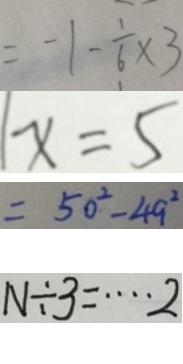Convert formula to latex. <formula><loc_0><loc_0><loc_500><loc_500>= - 1 - \frac { 1 } { 6 } \times 3 
 x = 5 
 = 5 0 ^ { 2 } - 4 9 ^ { 2 } 
 N \div 3 = \cdots 2</formula> 